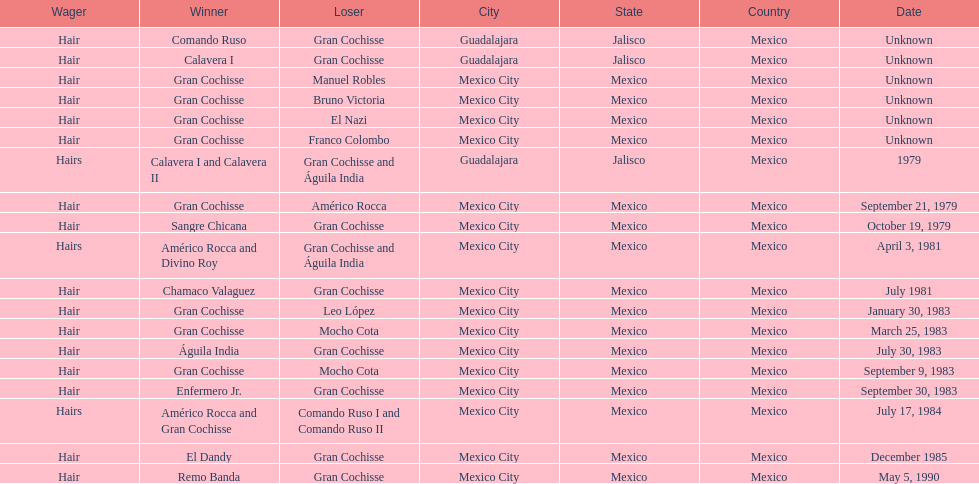Can you give me this table as a dict? {'header': ['Wager', 'Winner', 'Loser', 'City', 'State', 'Country', 'Date'], 'rows': [['Hair', 'Comando Ruso', 'Gran Cochisse', 'Guadalajara', 'Jalisco', 'Mexico', 'Unknown'], ['Hair', 'Calavera I', 'Gran Cochisse', 'Guadalajara', 'Jalisco', 'Mexico', 'Unknown'], ['Hair', 'Gran Cochisse', 'Manuel Robles', 'Mexico City', 'Mexico', 'Mexico', 'Unknown'], ['Hair', 'Gran Cochisse', 'Bruno Victoria', 'Mexico City', 'Mexico', 'Mexico', 'Unknown'], ['Hair', 'Gran Cochisse', 'El Nazi', 'Mexico City', 'Mexico', 'Mexico', 'Unknown'], ['Hair', 'Gran Cochisse', 'Franco Colombo', 'Mexico City', 'Mexico', 'Mexico', 'Unknown'], ['Hairs', 'Calavera I and Calavera II', 'Gran Cochisse and Águila India', 'Guadalajara', 'Jalisco', 'Mexico', '1979'], ['Hair', 'Gran Cochisse', 'Américo Rocca', 'Mexico City', 'Mexico', 'Mexico', 'September 21, 1979'], ['Hair', 'Sangre Chicana', 'Gran Cochisse', 'Mexico City', 'Mexico', 'Mexico', 'October 19, 1979'], ['Hairs', 'Américo Rocca and Divino Roy', 'Gran Cochisse and Águila India', 'Mexico City', 'Mexico', 'Mexico', 'April 3, 1981'], ['Hair', 'Chamaco Valaguez', 'Gran Cochisse', 'Mexico City', 'Mexico', 'Mexico', 'July 1981'], ['Hair', 'Gran Cochisse', 'Leo López', 'Mexico City', 'Mexico', 'Mexico', 'January 30, 1983'], ['Hair', 'Gran Cochisse', 'Mocho Cota', 'Mexico City', 'Mexico', 'Mexico', 'March 25, 1983'], ['Hair', 'Águila India', 'Gran Cochisse', 'Mexico City', 'Mexico', 'Mexico', 'July 30, 1983'], ['Hair', 'Gran Cochisse', 'Mocho Cota', 'Mexico City', 'Mexico', 'Mexico', 'September 9, 1983'], ['Hair', 'Enfermero Jr.', 'Gran Cochisse', 'Mexico City', 'Mexico', 'Mexico', 'September 30, 1983'], ['Hairs', 'Américo Rocca and Gran Cochisse', 'Comando Ruso I and Comando Ruso II', 'Mexico City', 'Mexico', 'Mexico', 'July 17, 1984'], ['Hair', 'El Dandy', 'Gran Cochisse', 'Mexico City', 'Mexico', 'Mexico', 'December 1985'], ['Hair', 'Remo Banda', 'Gran Cochisse', 'Mexico City', 'Mexico', 'Mexico', 'May 5, 1990']]} How many times has gran cochisse been a winner? 9. 